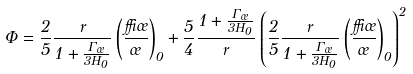<formula> <loc_0><loc_0><loc_500><loc_500>\Phi = \frac { 2 } { 5 } \frac { r } { 1 + \frac { \Gamma _ { \sigma } } { 3 H _ { 0 } } } \left ( \frac { \delta \sigma } { \sigma } \right ) _ { 0 } + \frac { 5 } { 4 } \frac { 1 + \frac { \Gamma _ { \sigma } } { 3 H _ { 0 } } } { r } \left ( \frac { 2 } { 5 } \frac { r } { 1 + \frac { \Gamma _ { \sigma } } { 3 H _ { 0 } } } \left ( \frac { \delta \sigma } { \sigma } \right ) _ { 0 } \right ) ^ { 2 }</formula> 